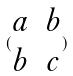Convert formula to latex. <formula><loc_0><loc_0><loc_500><loc_500>( \begin{matrix} a & b \\ b & c \end{matrix} )</formula> 